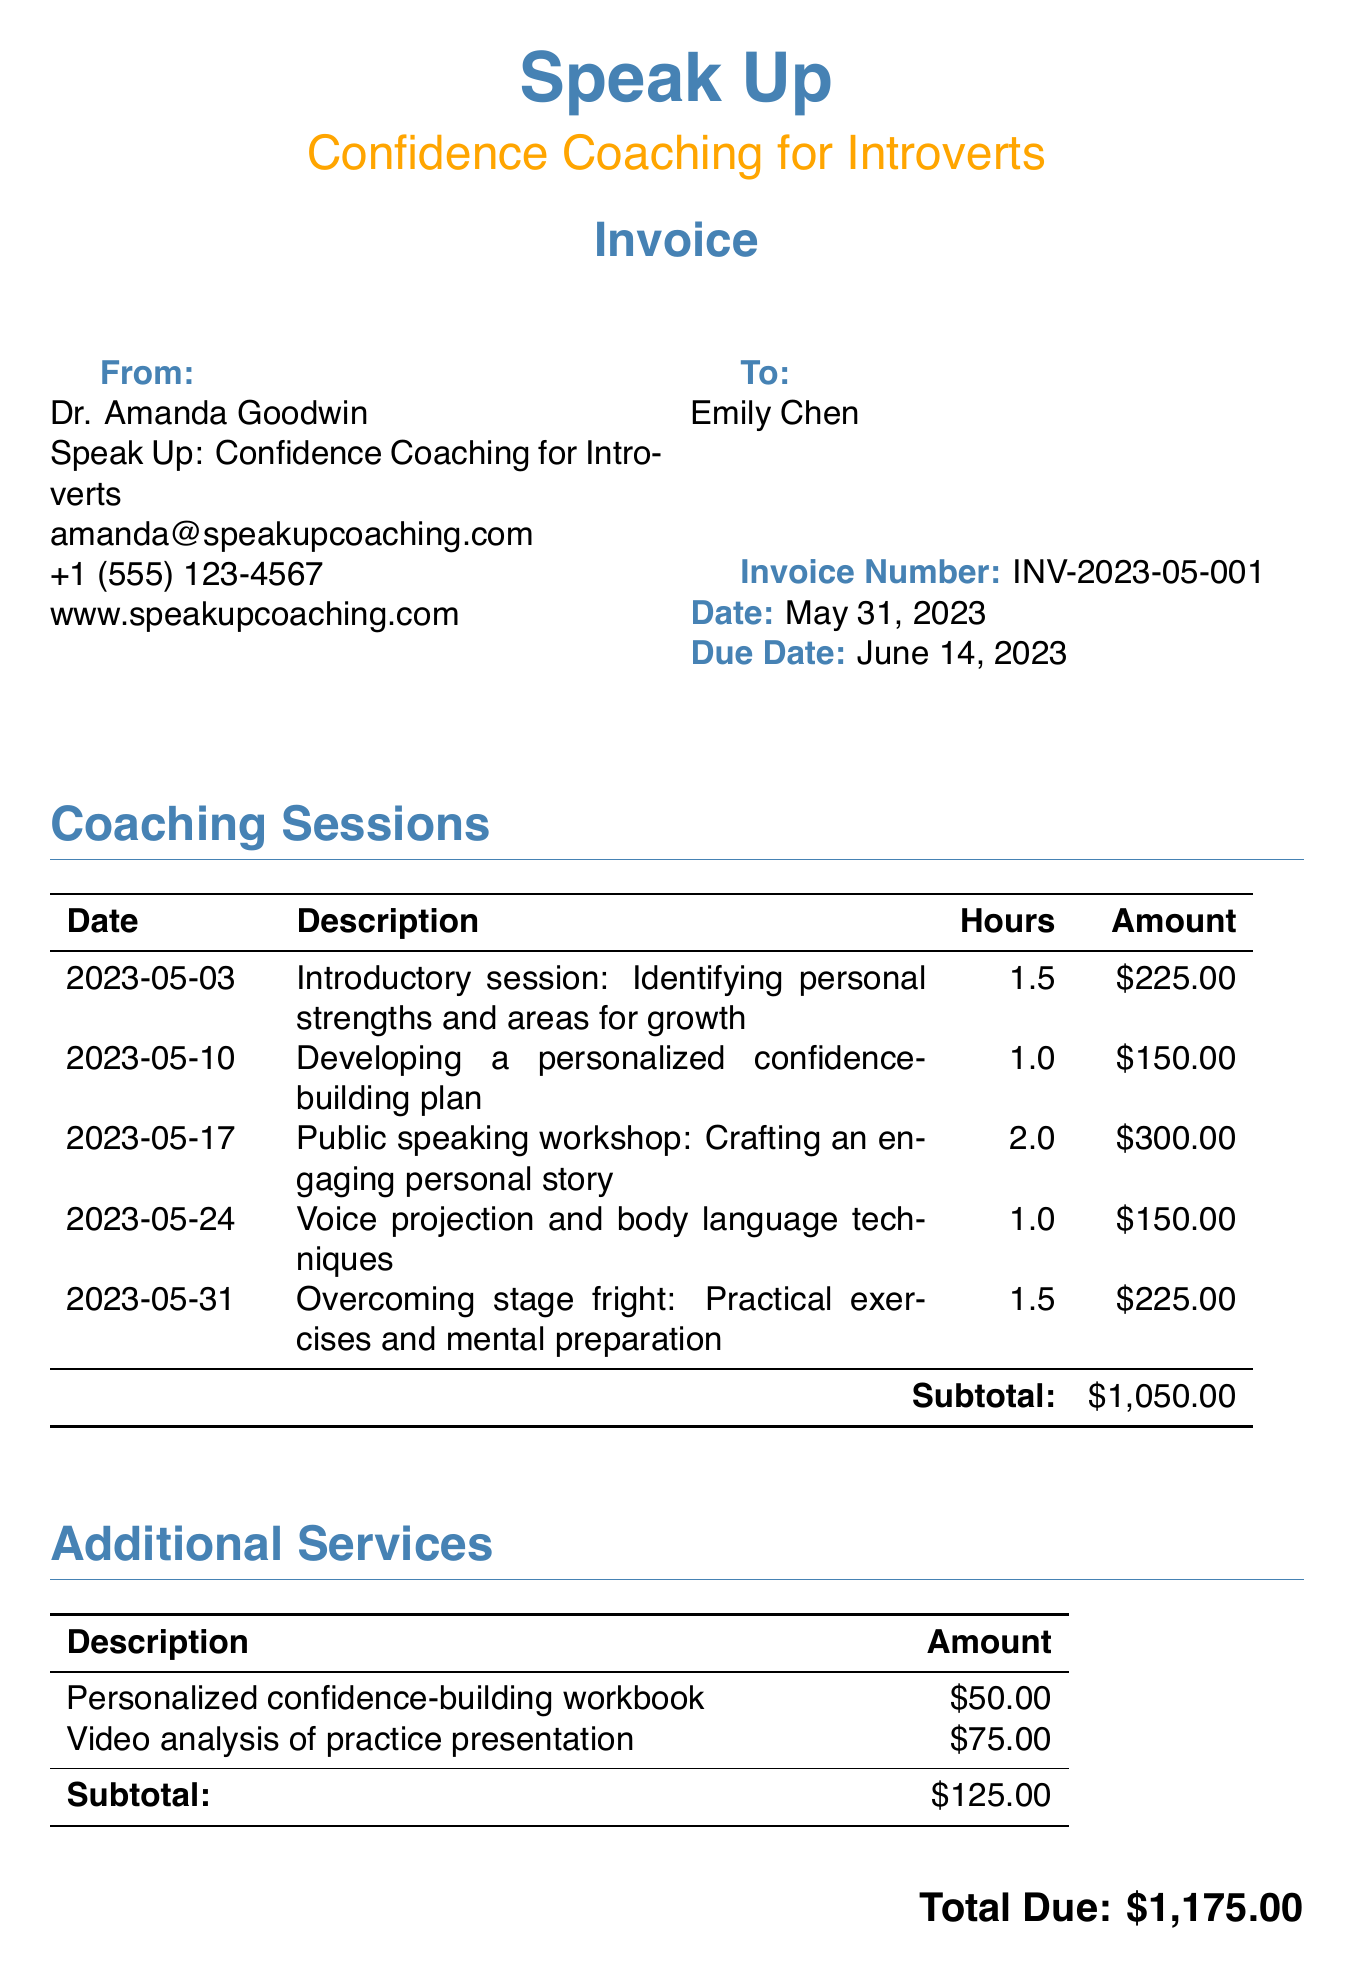What is the invoice number? The invoice number is a unique identifier for the document, which is provided in the top section.
Answer: INV-2023-05-001 Who is the client? The client details are provided in the "To:" section of the document.
Answer: Emily Chen What is the total amount due? The total amount due is calculated from the subtotals of coaching sessions and additional services combined.
Answer: $1,175.00 How many coaching sessions were held in May 2023? The number of coaching sessions is indicated in the "Coaching Sessions" section with each session listed separately.
Answer: 5 What is the date of the first session? The date of the first session is listed in the coaching sessions table.
Answer: 2023-05-03 What additional service had the highest cost? The additional services section lists the costs of each service, and the one with the highest cost can be identified from it.
Answer: Video analysis of practice presentation What is the hourly rate for coaching sessions? The hourly rate is specified in the document and is relevant for calculating the sessions' total cost.
Answer: $150 What is the payment method listed? The payment methods are detailed in the "Payment Details" section of the document.
Answer: Credit Card When is the payment due? The due date for the invoice can be found in the top section indicating the payment terms.
Answer: June 14, 2023 